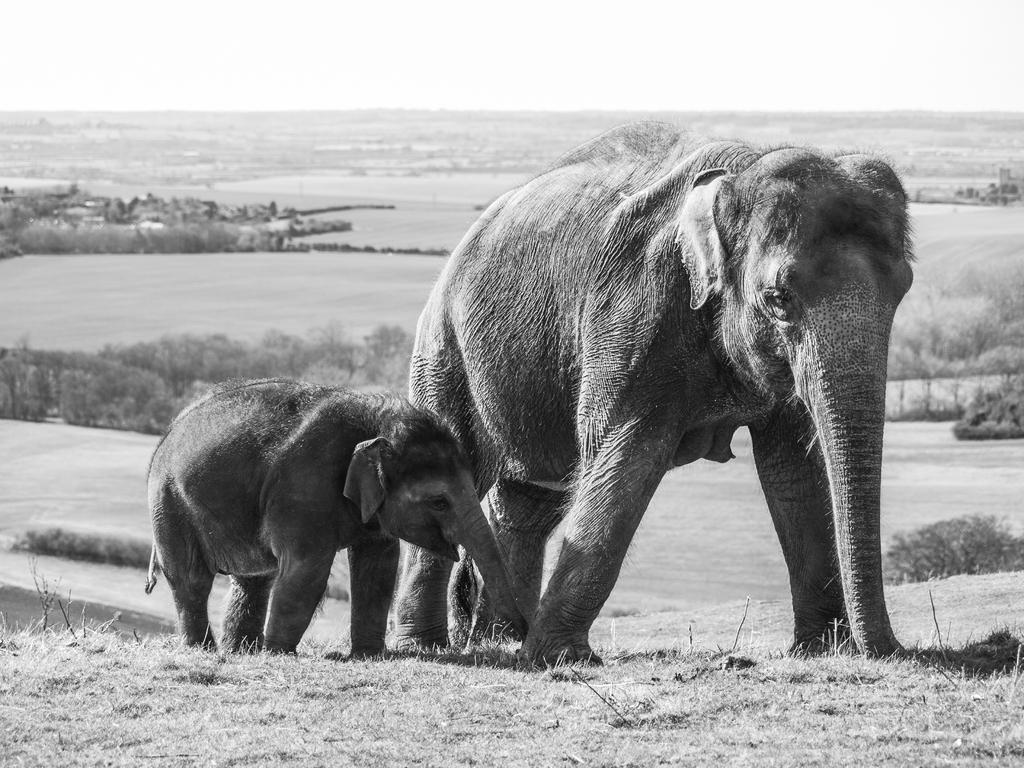What type of animal is present in the image? There is an elephant in the image. Can you describe the relationship between the two elephants in the image? There is a baby elephant in the image, suggesting a parent-child relationship. What are the elephants doing in the image? The elephants are walking. What can be seen in the background of the image? There are trees visible in the background of the image. What type of wing can be seen on the elephant in the image? There are no wings present on the elephant in the image. What does the mist smell like in the image? There is no mist present in the image, so it cannot be smelled. 